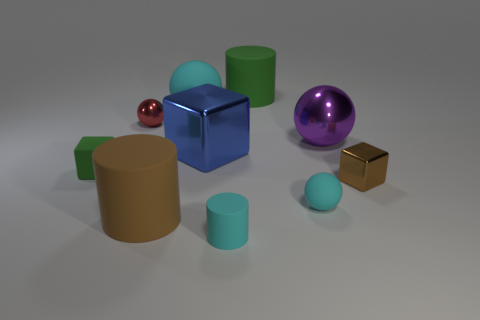Subtract all green matte cylinders. How many cylinders are left? 2 Subtract 1 cylinders. How many cylinders are left? 2 Subtract all red spheres. Subtract all red cylinders. How many spheres are left? 3 Subtract all brown blocks. How many yellow balls are left? 0 Subtract all cyan rubber cylinders. Subtract all small green matte blocks. How many objects are left? 8 Add 3 brown objects. How many brown objects are left? 5 Add 1 purple matte things. How many purple matte things exist? 1 Subtract all green cubes. How many cubes are left? 2 Subtract 0 green balls. How many objects are left? 10 Subtract all cubes. How many objects are left? 7 